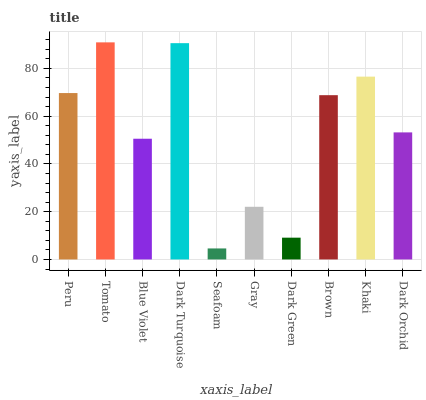Is Blue Violet the minimum?
Answer yes or no. No. Is Blue Violet the maximum?
Answer yes or no. No. Is Tomato greater than Blue Violet?
Answer yes or no. Yes. Is Blue Violet less than Tomato?
Answer yes or no. Yes. Is Blue Violet greater than Tomato?
Answer yes or no. No. Is Tomato less than Blue Violet?
Answer yes or no. No. Is Brown the high median?
Answer yes or no. Yes. Is Dark Orchid the low median?
Answer yes or no. Yes. Is Tomato the high median?
Answer yes or no. No. Is Dark Green the low median?
Answer yes or no. No. 